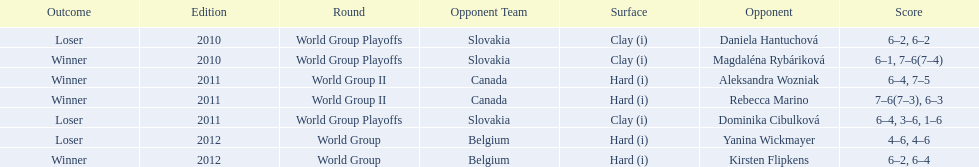Quantity of games in the contest versus dominika cibulkova? 3. 